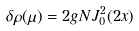<formula> <loc_0><loc_0><loc_500><loc_500>\delta \rho ( \mu ) = 2 g N J _ { 0 } ^ { 2 } ( 2 x )</formula> 